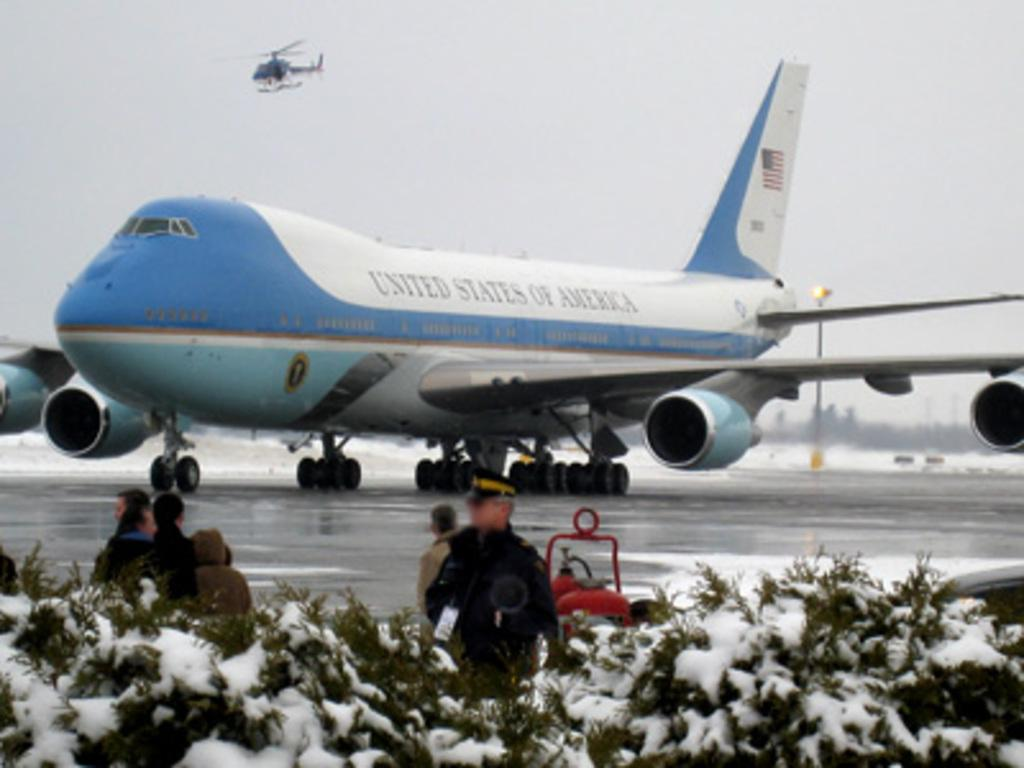<image>
Relay a brief, clear account of the picture shown. Air Force One has UNITED STATES OF AMERICA on the fuselage. 